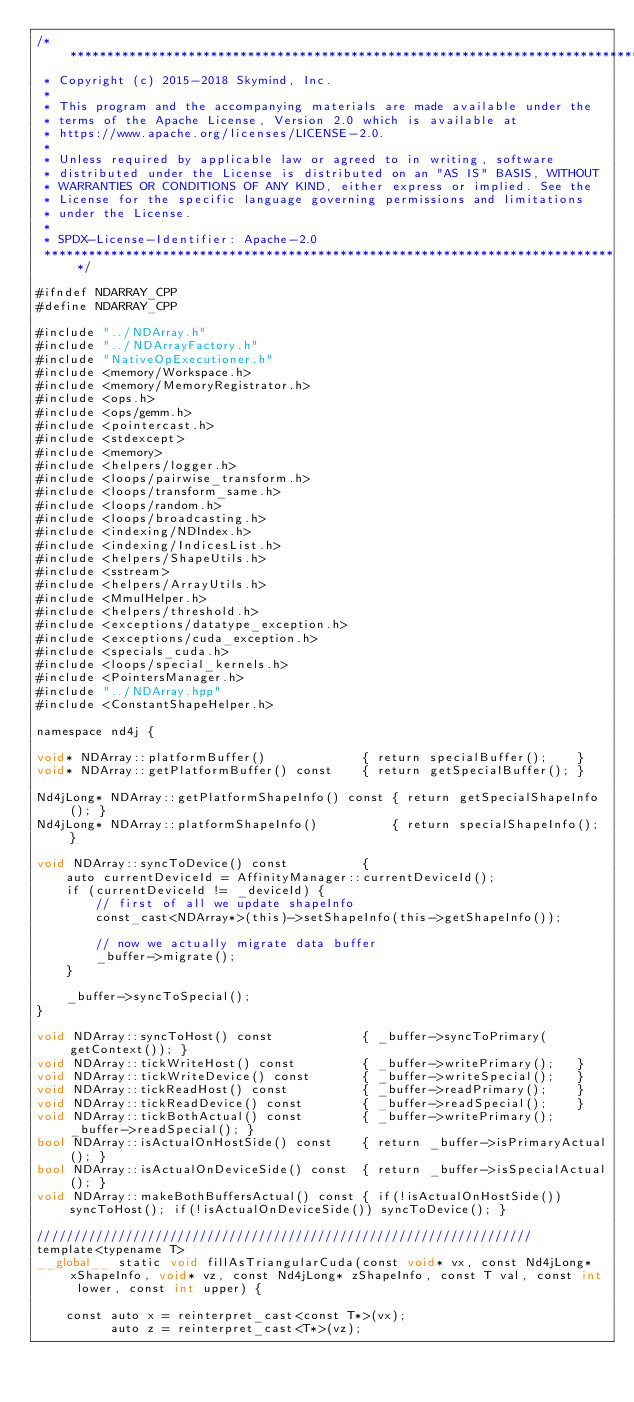<code> <loc_0><loc_0><loc_500><loc_500><_Cuda_>/*******************************************************************************
 * Copyright (c) 2015-2018 Skymind, Inc.
 *
 * This program and the accompanying materials are made available under the
 * terms of the Apache License, Version 2.0 which is available at
 * https://www.apache.org/licenses/LICENSE-2.0.
 *
 * Unless required by applicable law or agreed to in writing, software
 * distributed under the License is distributed on an "AS IS" BASIS, WITHOUT
 * WARRANTIES OR CONDITIONS OF ANY KIND, either express or implied. See the
 * License for the specific language governing permissions and limitations
 * under the License.
 *
 * SPDX-License-Identifier: Apache-2.0
 ******************************************************************************/

#ifndef NDARRAY_CPP
#define NDARRAY_CPP

#include "../NDArray.h"
#include "../NDArrayFactory.h"
#include "NativeOpExecutioner.h"
#include <memory/Workspace.h>
#include <memory/MemoryRegistrator.h>
#include <ops.h>
#include <ops/gemm.h>
#include <pointercast.h>
#include <stdexcept>
#include <memory>
#include <helpers/logger.h>
#include <loops/pairwise_transform.h>
#include <loops/transform_same.h>
#include <loops/random.h>
#include <loops/broadcasting.h>
#include <indexing/NDIndex.h>
#include <indexing/IndicesList.h>
#include <helpers/ShapeUtils.h>
#include <sstream>
#include <helpers/ArrayUtils.h>
#include <MmulHelper.h>
#include <helpers/threshold.h>
#include <exceptions/datatype_exception.h>
#include <exceptions/cuda_exception.h>
#include <specials_cuda.h>
#include <loops/special_kernels.h>
#include <PointersManager.h>
#include "../NDArray.hpp"
#include <ConstantShapeHelper.h>

namespace nd4j {

void* NDArray::platformBuffer()             { return specialBuffer();    }
void* NDArray::getPlatformBuffer() const    { return getSpecialBuffer(); }

Nd4jLong* NDArray::getPlatformShapeInfo() const { return getSpecialShapeInfo(); }
Nd4jLong* NDArray::platformShapeInfo()          { return specialShapeInfo(); }

void NDArray::syncToDevice() const          {
    auto currentDeviceId = AffinityManager::currentDeviceId();
    if (currentDeviceId != _deviceId) {
        // first of all we update shapeInfo
        const_cast<NDArray*>(this)->setShapeInfo(this->getShapeInfo());

        // now we actually migrate data buffer
        _buffer->migrate();
    }

    _buffer->syncToSpecial();
}

void NDArray::syncToHost() const            { _buffer->syncToPrimary(getContext()); }
void NDArray::tickWriteHost() const         { _buffer->writePrimary();   }
void NDArray::tickWriteDevice() const       { _buffer->writeSpecial();   }
void NDArray::tickReadHost() const          { _buffer->readPrimary();    }
void NDArray::tickReadDevice() const        { _buffer->readSpecial();    }
void NDArray::tickBothActual() const        { _buffer->writePrimary(); _buffer->readSpecial(); }
bool NDArray::isActualOnHostSide() const    { return _buffer->isPrimaryActual(); }
bool NDArray::isActualOnDeviceSide() const  { return _buffer->isSpecialActual(); }
void NDArray::makeBothBuffersActual() const { if(!isActualOnHostSide()) syncToHost(); if(!isActualOnDeviceSide()) syncToDevice(); }

///////////////////////////////////////////////////////////////////
template<typename T>
__global__ static void fillAsTriangularCuda(const void* vx, const Nd4jLong* xShapeInfo, void* vz, const Nd4jLong* zShapeInfo, const T val, const int lower, const int upper) {

    const auto x = reinterpret_cast<const T*>(vx);
          auto z = reinterpret_cast<T*>(vz);
</code> 